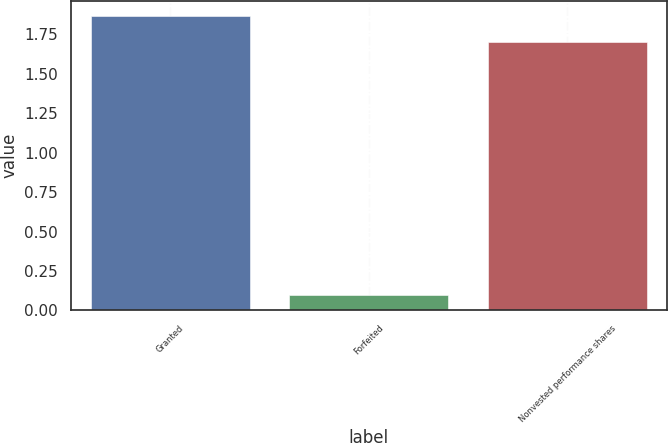Convert chart to OTSL. <chart><loc_0><loc_0><loc_500><loc_500><bar_chart><fcel>Granted<fcel>Forfeited<fcel>Nonvested performance shares<nl><fcel>1.87<fcel>0.1<fcel>1.7<nl></chart> 